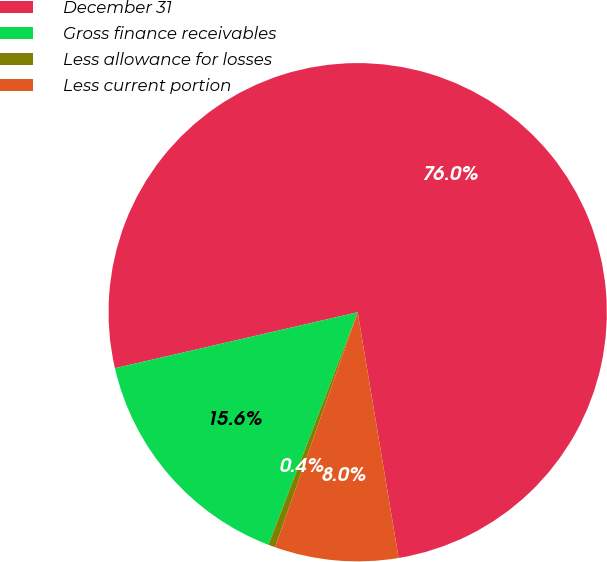Convert chart to OTSL. <chart><loc_0><loc_0><loc_500><loc_500><pie_chart><fcel>December 31<fcel>Gross finance receivables<fcel>Less allowance for losses<fcel>Less current portion<nl><fcel>75.98%<fcel>15.56%<fcel>0.45%<fcel>8.01%<nl></chart> 